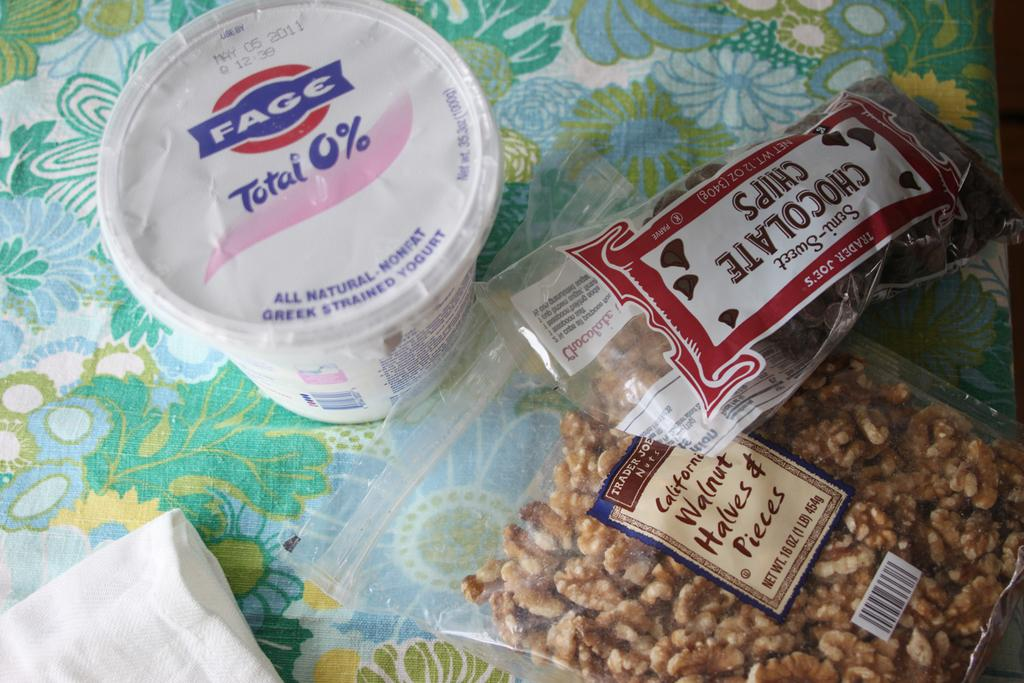What type of food item is featured in the first packet in the image? There is a chocolate packet in the image. What type of food item is featured in the second packet in the image? There is a walnut packet in the image. What can be used for cleaning or wiping in the image? There is tissue in the image. What type of dairy product is featured in the image? There is a yogurt box in the image. What religious symbol can be seen in the image? There is no religious symbol present in the image. What angle is the yogurt box positioned at in the image? The angle of the yogurt box cannot be determined from the image, as it is not mentioned in the provided facts. 